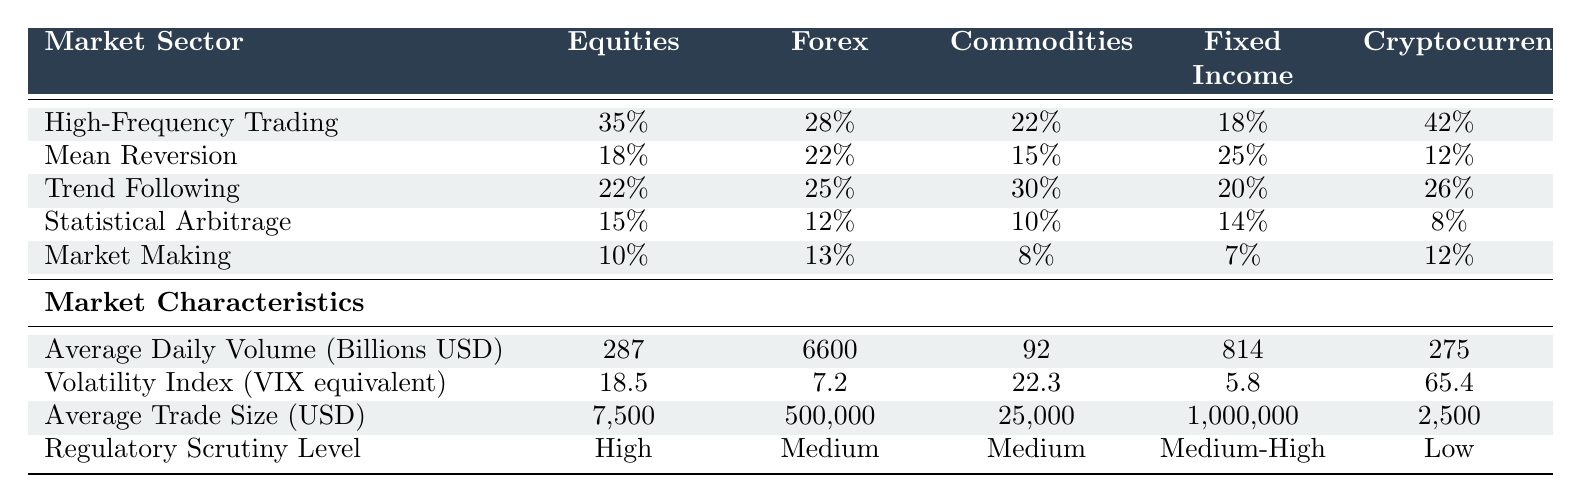What is the highest percentage of High-Frequency Trading in a market sector? The highest percentage of High-Frequency Trading is 42%, which is found in the Cryptocurrencies sector.
Answer: 42% Which market sector has the lowest Average Daily Volume? The market sector with the lowest Average Daily Volume is Commodities, with an average of 92 billion USD.
Answer: Commodities Is the Volatility Index for Fixed Income higher than that for Equities? The Volatility Index for Fixed Income is 5.8, which is lower than that for Equities at 18.5. Therefore, the statement is false.
Answer: False What is the difference in percentage between High-Frequency Trading and Market Making in the Forex market? High-Frequency Trading in the Forex market is at 28% and Market Making is at 13%. The difference is 28% - 13% = 15%.
Answer: 15% In which market sector is Mean Reversion most prevalent? Mean Reversion is most prevalent in the Fixed Income sector, where it represents 25%.
Answer: Fixed Income Summing the percentages of all trading algorithm types in the Commodities sector, what total do we get? To find the total, we sum the percentages: 22% (High-Frequency Trading) + 15% (Mean Reversion) + 30% (Trend Following) + 10% (Statistical Arbitrage) + 8% (Market Making) = 85%.
Answer: 85% Which trading algorithm type has the lowest prevalence across all sectors? The trading algorithm type with the lowest prevalence across all sectors is Statistical Arbitrage, particularly in the Cryptocurrencies sector at 8%.
Answer: Statistical Arbitrage What is the average Average Trade Size across all market sectors? To find the average Average Trade Size, we sum all the values: 7500 + 500000 + 25000 + 1000000 + 2500 = 1,532,000 USD. Then, we divide by the number of sectors (5) to get 1,532,000 / 5 = 306,400 USD.
Answer: 306,400 USD Is there a market sector where Trend Following is more prevalent than High-Frequency Trading? Yes, in the Cryptocurrencies sector, Trend Following is at 26%, which is higher than High-Frequency Trading at 42%, making that statement false.
Answer: False Which market sector demonstrates the highest volatility index? The market sector with the highest Volatility Index is Cryptocurrencies, with a value of 65.4.
Answer: Cryptocurrencies 